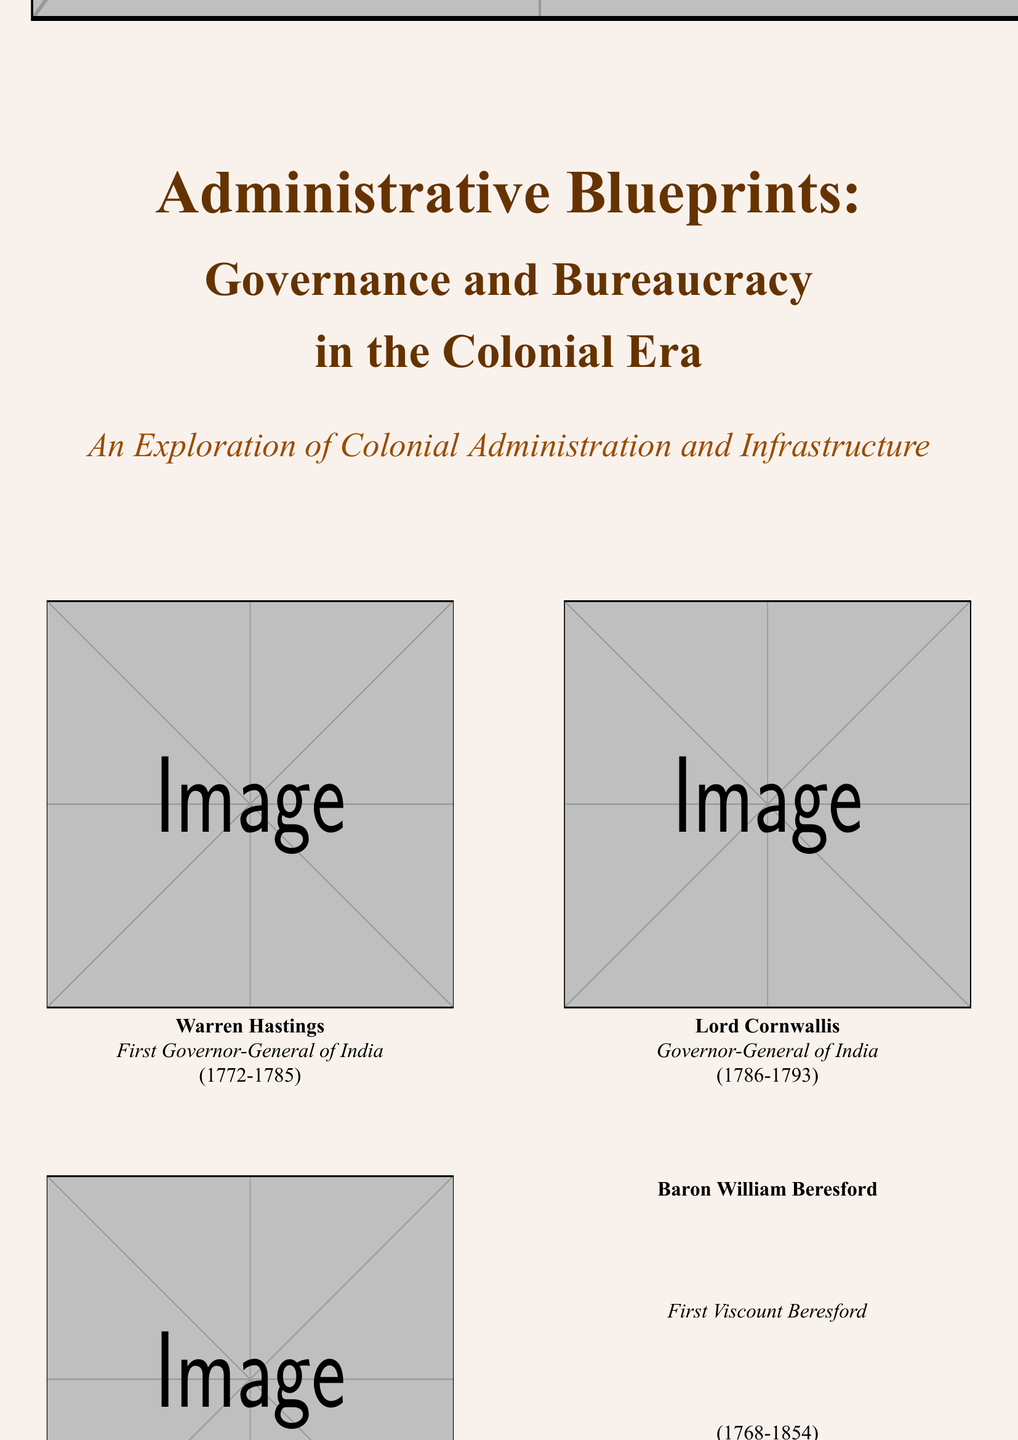What is the title of the book? The title is prominently displayed in large font on the cover of the document.
Answer: Administrative Blueprints Who is the first Governor-General of India mentioned? The document lists notable colonial administrators along with their titles and terms.
Answer: Warren Hastings What years did Lord Cornwallis serve as Governor-General of India? The years are provided next to Lord Cornwallis's name in the document.
Answer: 1786-1793 What is the subtitle of the book? The subtitle is mentioned below the main title, providing additional context.
Answer: An Exploration of Colonial Administration and Infrastructure Which notable colonial administrator was the Lieutenant-Governor of the Dutch East Indies? The document specifies the titles and terms of various administrators.
Answer: Sir Stamford Raffles What is the primary focus of the book as indicated in the footer? The footer contains a concise description of the content focus, highlighting key themes.
Answer: Colonial administrative frameworks What color is the background of the document? The background color is specifically mentioned as part of the design choices in the document.
Answer: Brown How many images of notable administrators are featured on the cover? The document shows a clear layout of images placed in a two-column format.
Answer: Four 